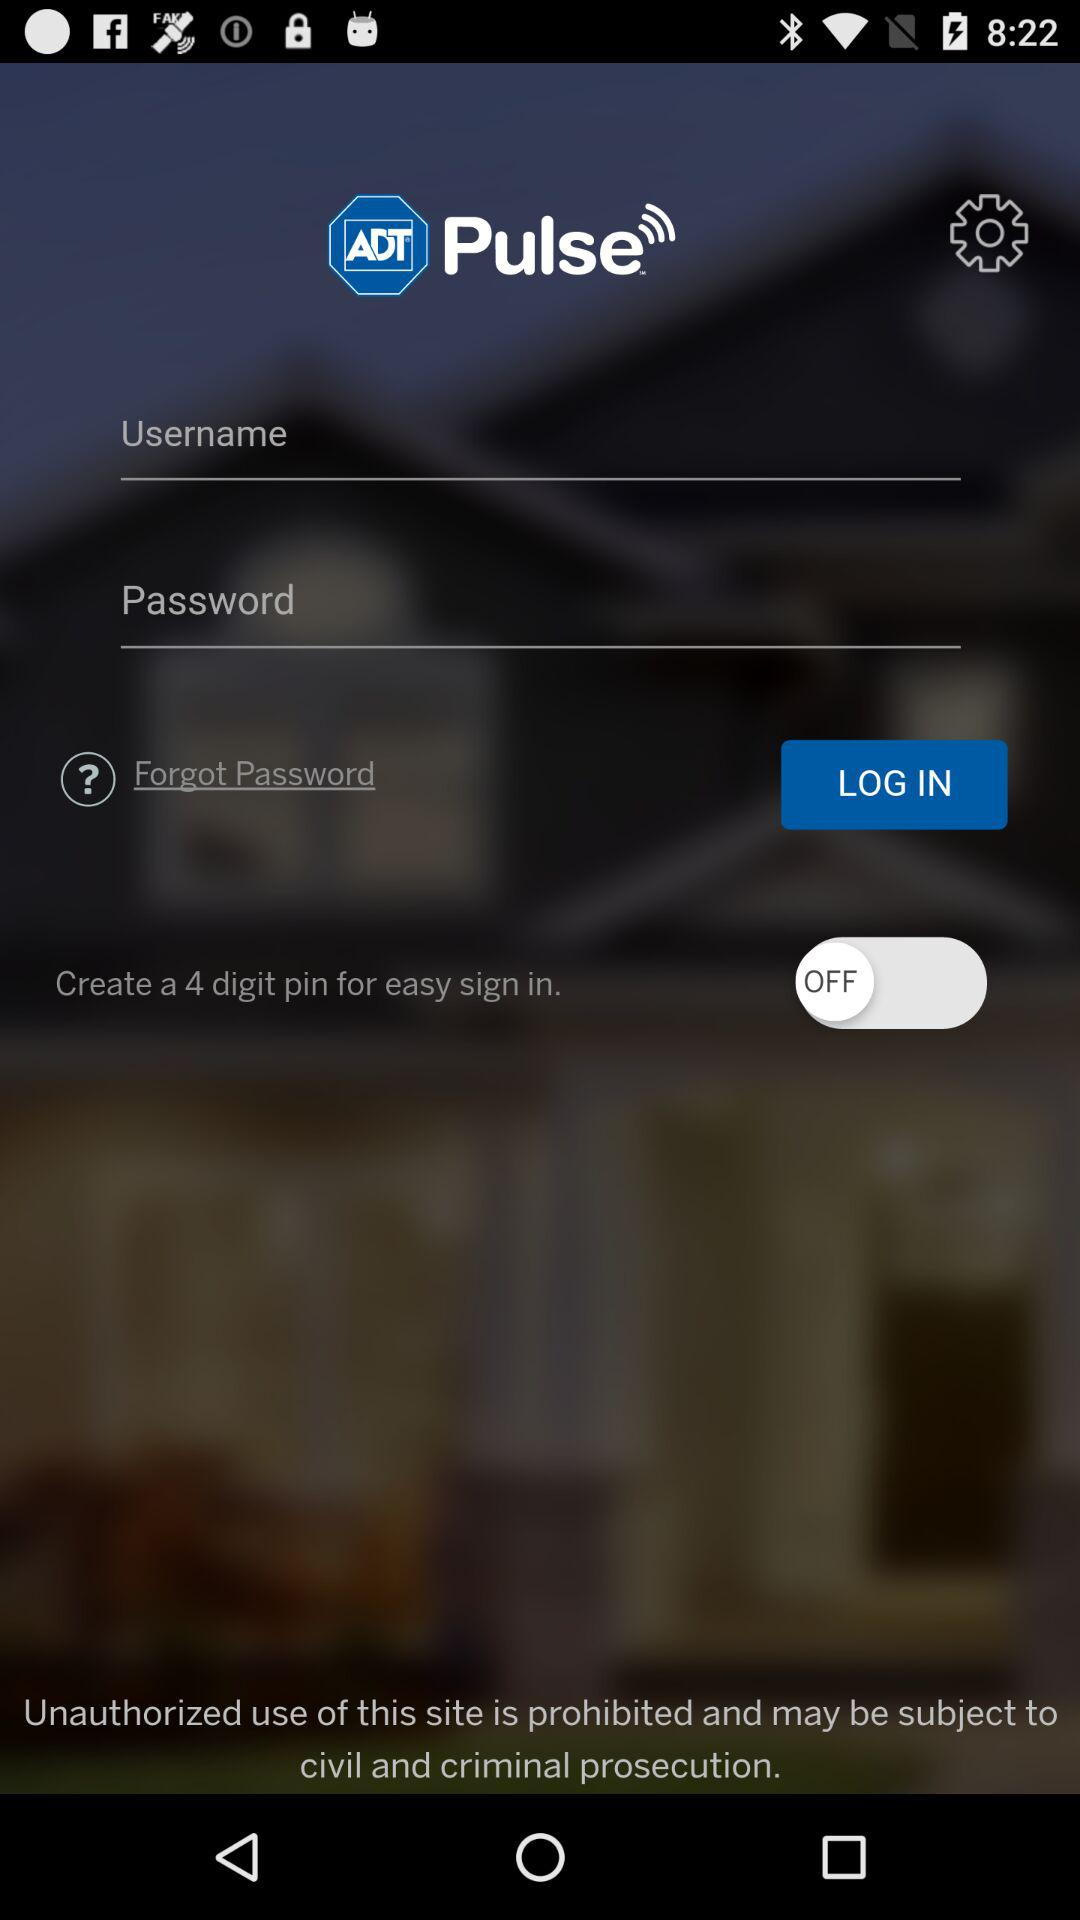What is the status of "Create a 4 digit pin for easy sign in."? The status is "off". 